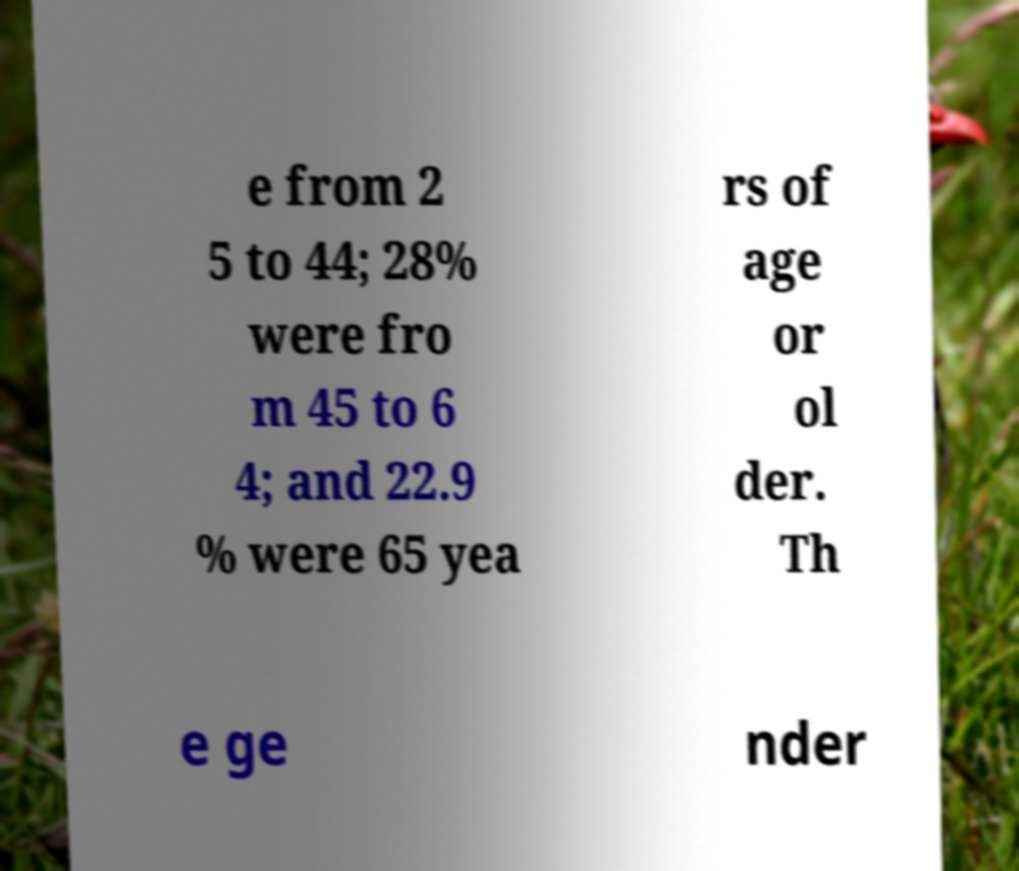Please identify and transcribe the text found in this image. e from 2 5 to 44; 28% were fro m 45 to 6 4; and 22.9 % were 65 yea rs of age or ol der. Th e ge nder 